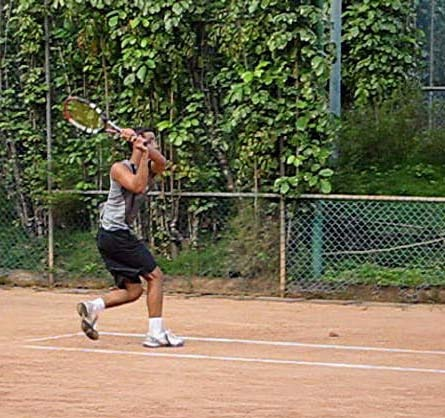Describe the objects in this image and their specific colors. I can see people in gray, black, brown, and lightgray tones and tennis racket in gray, olive, and black tones in this image. 